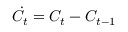<formula> <loc_0><loc_0><loc_500><loc_500>\dot { C } _ { t } = { C } _ { t } - { C } _ { t - 1 }</formula> 